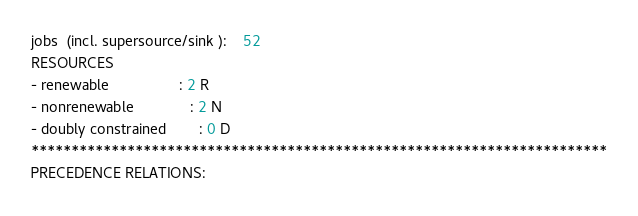Convert code to text. <code><loc_0><loc_0><loc_500><loc_500><_ObjectiveC_>jobs  (incl. supersource/sink ):	52
RESOURCES
- renewable                 : 2 R
- nonrenewable              : 2 N
- doubly constrained        : 0 D
************************************************************************
PRECEDENCE RELATIONS:</code> 